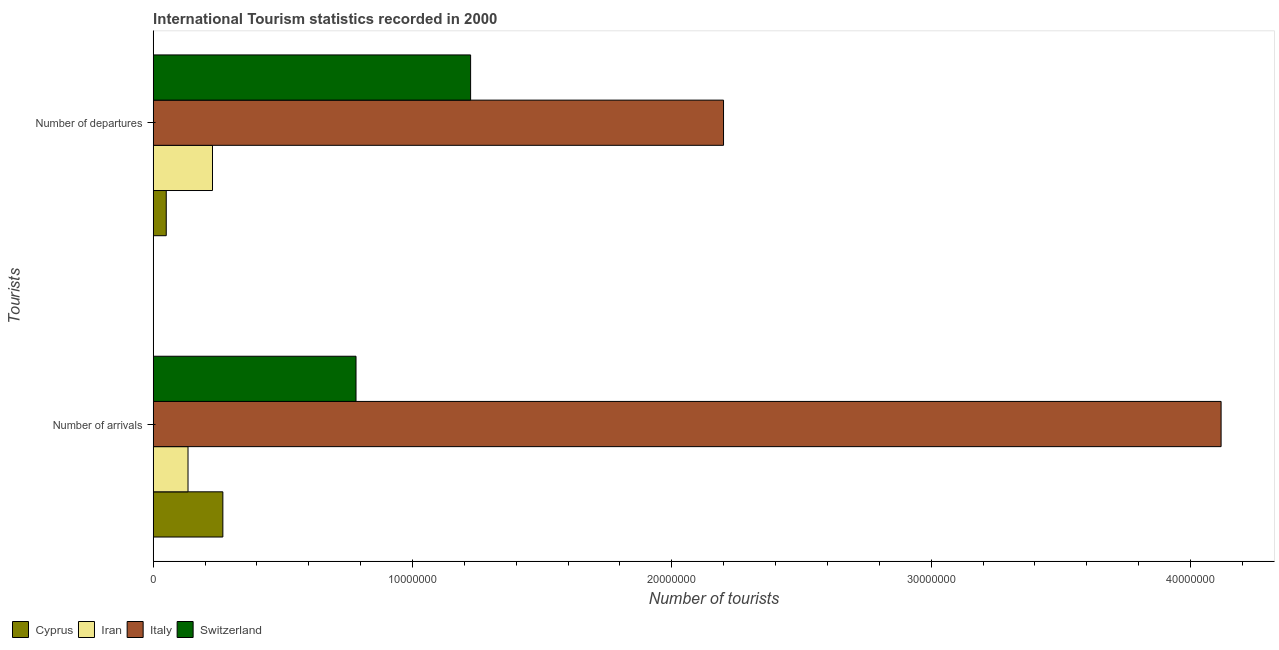How many different coloured bars are there?
Give a very brief answer. 4. How many groups of bars are there?
Make the answer very short. 2. How many bars are there on the 1st tick from the top?
Ensure brevity in your answer.  4. How many bars are there on the 2nd tick from the bottom?
Give a very brief answer. 4. What is the label of the 1st group of bars from the top?
Offer a very short reply. Number of departures. What is the number of tourist arrivals in Cyprus?
Keep it short and to the point. 2.69e+06. Across all countries, what is the maximum number of tourist departures?
Offer a very short reply. 2.20e+07. Across all countries, what is the minimum number of tourist departures?
Your response must be concise. 5.03e+05. In which country was the number of tourist departures minimum?
Offer a terse response. Cyprus. What is the total number of tourist arrivals in the graph?
Provide a short and direct response. 5.30e+07. What is the difference between the number of tourist departures in Switzerland and that in Cyprus?
Provide a succinct answer. 1.17e+07. What is the difference between the number of tourist arrivals in Italy and the number of tourist departures in Iran?
Provide a short and direct response. 3.89e+07. What is the average number of tourist departures per country?
Provide a short and direct response. 9.26e+06. What is the difference between the number of tourist arrivals and number of tourist departures in Iran?
Ensure brevity in your answer.  -9.44e+05. What is the ratio of the number of tourist departures in Cyprus to that in Switzerland?
Offer a terse response. 0.04. In how many countries, is the number of tourist arrivals greater than the average number of tourist arrivals taken over all countries?
Keep it short and to the point. 1. What does the 3rd bar from the top in Number of arrivals represents?
Your answer should be compact. Iran. What does the 1st bar from the bottom in Number of departures represents?
Your response must be concise. Cyprus. How many bars are there?
Your answer should be compact. 8. Are all the bars in the graph horizontal?
Make the answer very short. Yes. What is the title of the graph?
Your answer should be compact. International Tourism statistics recorded in 2000. Does "Sweden" appear as one of the legend labels in the graph?
Give a very brief answer. No. What is the label or title of the X-axis?
Provide a succinct answer. Number of tourists. What is the label or title of the Y-axis?
Make the answer very short. Tourists. What is the Number of tourists in Cyprus in Number of arrivals?
Provide a short and direct response. 2.69e+06. What is the Number of tourists in Iran in Number of arrivals?
Ensure brevity in your answer.  1.34e+06. What is the Number of tourists in Italy in Number of arrivals?
Give a very brief answer. 4.12e+07. What is the Number of tourists of Switzerland in Number of arrivals?
Give a very brief answer. 7.82e+06. What is the Number of tourists in Cyprus in Number of departures?
Ensure brevity in your answer.  5.03e+05. What is the Number of tourists of Iran in Number of departures?
Your answer should be compact. 2.29e+06. What is the Number of tourists of Italy in Number of departures?
Keep it short and to the point. 2.20e+07. What is the Number of tourists of Switzerland in Number of departures?
Your response must be concise. 1.22e+07. Across all Tourists, what is the maximum Number of tourists in Cyprus?
Your answer should be very brief. 2.69e+06. Across all Tourists, what is the maximum Number of tourists of Iran?
Make the answer very short. 2.29e+06. Across all Tourists, what is the maximum Number of tourists in Italy?
Keep it short and to the point. 4.12e+07. Across all Tourists, what is the maximum Number of tourists of Switzerland?
Your answer should be compact. 1.22e+07. Across all Tourists, what is the minimum Number of tourists in Cyprus?
Provide a short and direct response. 5.03e+05. Across all Tourists, what is the minimum Number of tourists in Iran?
Your response must be concise. 1.34e+06. Across all Tourists, what is the minimum Number of tourists in Italy?
Offer a very short reply. 2.20e+07. Across all Tourists, what is the minimum Number of tourists of Switzerland?
Offer a very short reply. 7.82e+06. What is the total Number of tourists of Cyprus in the graph?
Provide a succinct answer. 3.19e+06. What is the total Number of tourists of Iran in the graph?
Your answer should be very brief. 3.63e+06. What is the total Number of tourists of Italy in the graph?
Ensure brevity in your answer.  6.32e+07. What is the total Number of tourists of Switzerland in the graph?
Provide a succinct answer. 2.01e+07. What is the difference between the Number of tourists of Cyprus in Number of arrivals and that in Number of departures?
Make the answer very short. 2.18e+06. What is the difference between the Number of tourists of Iran in Number of arrivals and that in Number of departures?
Ensure brevity in your answer.  -9.44e+05. What is the difference between the Number of tourists in Italy in Number of arrivals and that in Number of departures?
Offer a very short reply. 1.92e+07. What is the difference between the Number of tourists of Switzerland in Number of arrivals and that in Number of departures?
Provide a short and direct response. -4.42e+06. What is the difference between the Number of tourists in Cyprus in Number of arrivals and the Number of tourists in Iran in Number of departures?
Give a very brief answer. 4.00e+05. What is the difference between the Number of tourists of Cyprus in Number of arrivals and the Number of tourists of Italy in Number of departures?
Provide a succinct answer. -1.93e+07. What is the difference between the Number of tourists of Cyprus in Number of arrivals and the Number of tourists of Switzerland in Number of departures?
Your answer should be very brief. -9.55e+06. What is the difference between the Number of tourists in Iran in Number of arrivals and the Number of tourists in Italy in Number of departures?
Give a very brief answer. -2.07e+07. What is the difference between the Number of tourists of Iran in Number of arrivals and the Number of tourists of Switzerland in Number of departures?
Ensure brevity in your answer.  -1.09e+07. What is the difference between the Number of tourists in Italy in Number of arrivals and the Number of tourists in Switzerland in Number of departures?
Provide a succinct answer. 2.89e+07. What is the average Number of tourists in Cyprus per Tourists?
Your answer should be very brief. 1.59e+06. What is the average Number of tourists of Iran per Tourists?
Ensure brevity in your answer.  1.81e+06. What is the average Number of tourists in Italy per Tourists?
Give a very brief answer. 3.16e+07. What is the average Number of tourists in Switzerland per Tourists?
Your answer should be very brief. 1.00e+07. What is the difference between the Number of tourists of Cyprus and Number of tourists of Iran in Number of arrivals?
Provide a short and direct response. 1.34e+06. What is the difference between the Number of tourists of Cyprus and Number of tourists of Italy in Number of arrivals?
Make the answer very short. -3.85e+07. What is the difference between the Number of tourists of Cyprus and Number of tourists of Switzerland in Number of arrivals?
Make the answer very short. -5.14e+06. What is the difference between the Number of tourists in Iran and Number of tourists in Italy in Number of arrivals?
Make the answer very short. -3.98e+07. What is the difference between the Number of tourists in Iran and Number of tourists in Switzerland in Number of arrivals?
Provide a short and direct response. -6.48e+06. What is the difference between the Number of tourists of Italy and Number of tourists of Switzerland in Number of arrivals?
Ensure brevity in your answer.  3.34e+07. What is the difference between the Number of tourists of Cyprus and Number of tourists of Iran in Number of departures?
Provide a succinct answer. -1.78e+06. What is the difference between the Number of tourists in Cyprus and Number of tourists in Italy in Number of departures?
Make the answer very short. -2.15e+07. What is the difference between the Number of tourists of Cyprus and Number of tourists of Switzerland in Number of departures?
Ensure brevity in your answer.  -1.17e+07. What is the difference between the Number of tourists of Iran and Number of tourists of Italy in Number of departures?
Your response must be concise. -1.97e+07. What is the difference between the Number of tourists in Iran and Number of tourists in Switzerland in Number of departures?
Ensure brevity in your answer.  -9.95e+06. What is the difference between the Number of tourists of Italy and Number of tourists of Switzerland in Number of departures?
Offer a very short reply. 9.75e+06. What is the ratio of the Number of tourists in Cyprus in Number of arrivals to that in Number of departures?
Offer a terse response. 5.34. What is the ratio of the Number of tourists in Iran in Number of arrivals to that in Number of departures?
Offer a very short reply. 0.59. What is the ratio of the Number of tourists of Italy in Number of arrivals to that in Number of departures?
Make the answer very short. 1.87. What is the ratio of the Number of tourists in Switzerland in Number of arrivals to that in Number of departures?
Provide a succinct answer. 0.64. What is the difference between the highest and the second highest Number of tourists of Cyprus?
Provide a succinct answer. 2.18e+06. What is the difference between the highest and the second highest Number of tourists in Iran?
Your answer should be very brief. 9.44e+05. What is the difference between the highest and the second highest Number of tourists in Italy?
Ensure brevity in your answer.  1.92e+07. What is the difference between the highest and the second highest Number of tourists in Switzerland?
Provide a succinct answer. 4.42e+06. What is the difference between the highest and the lowest Number of tourists in Cyprus?
Your response must be concise. 2.18e+06. What is the difference between the highest and the lowest Number of tourists of Iran?
Keep it short and to the point. 9.44e+05. What is the difference between the highest and the lowest Number of tourists in Italy?
Your answer should be compact. 1.92e+07. What is the difference between the highest and the lowest Number of tourists in Switzerland?
Provide a short and direct response. 4.42e+06. 